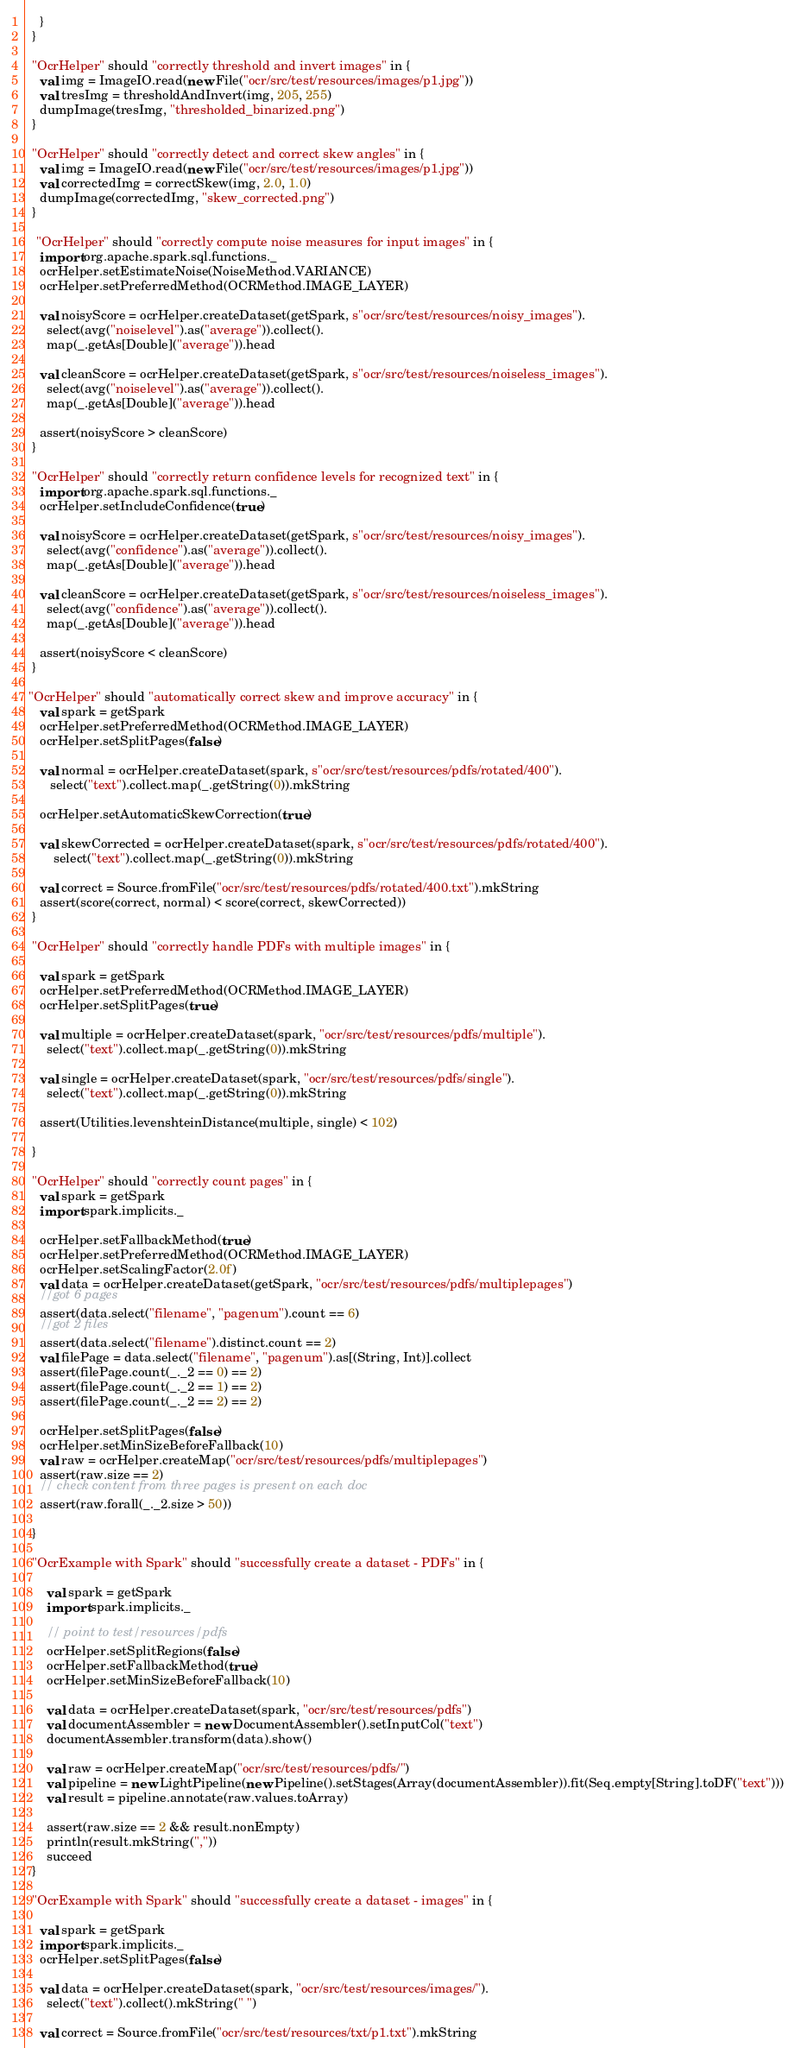<code> <loc_0><loc_0><loc_500><loc_500><_Scala_>    }
  }

  "OcrHelper" should "correctly threshold and invert images" in {
    val img = ImageIO.read(new File("ocr/src/test/resources/images/p1.jpg"))
    val tresImg = thresholdAndInvert(img, 205, 255)
    dumpImage(tresImg, "thresholded_binarized.png")
  }

  "OcrHelper" should "correctly detect and correct skew angles" in {
    val img = ImageIO.read(new File("ocr/src/test/resources/images/p1.jpg"))
    val correctedImg = correctSkew(img, 2.0, 1.0)
    dumpImage(correctedImg, "skew_corrected.png")
  }

   "OcrHelper" should "correctly compute noise measures for input images" in {
    import org.apache.spark.sql.functions._
    ocrHelper.setEstimateNoise(NoiseMethod.VARIANCE)
    ocrHelper.setPreferredMethod(OCRMethod.IMAGE_LAYER)

    val noisyScore = ocrHelper.createDataset(getSpark, s"ocr/src/test/resources/noisy_images").
      select(avg("noiselevel").as("average")).collect().
      map(_.getAs[Double]("average")).head

    val cleanScore = ocrHelper.createDataset(getSpark, s"ocr/src/test/resources/noiseless_images").
      select(avg("noiselevel").as("average")).collect().
      map(_.getAs[Double]("average")).head

    assert(noisyScore > cleanScore)
  }

  "OcrHelper" should "correctly return confidence levels for recognized text" in {
    import org.apache.spark.sql.functions._
    ocrHelper.setIncludeConfidence(true)

    val noisyScore = ocrHelper.createDataset(getSpark, s"ocr/src/test/resources/noisy_images").
      select(avg("confidence").as("average")).collect().
      map(_.getAs[Double]("average")).head

    val cleanScore = ocrHelper.createDataset(getSpark, s"ocr/src/test/resources/noiseless_images").
      select(avg("confidence").as("average")).collect().
      map(_.getAs[Double]("average")).head

    assert(noisyScore < cleanScore)
  }

 "OcrHelper" should "automatically correct skew and improve accuracy" in {
    val spark = getSpark
    ocrHelper.setPreferredMethod(OCRMethod.IMAGE_LAYER)
    ocrHelper.setSplitPages(false)

    val normal = ocrHelper.createDataset(spark, s"ocr/src/test/resources/pdfs/rotated/400").
       select("text").collect.map(_.getString(0)).mkString

    ocrHelper.setAutomaticSkewCorrection(true)

    val skewCorrected = ocrHelper.createDataset(spark, s"ocr/src/test/resources/pdfs/rotated/400").
        select("text").collect.map(_.getString(0)).mkString

    val correct = Source.fromFile("ocr/src/test/resources/pdfs/rotated/400.txt").mkString
    assert(score(correct, normal) < score(correct, skewCorrected))
  }

  "OcrHelper" should "correctly handle PDFs with multiple images" in {

    val spark = getSpark
    ocrHelper.setPreferredMethod(OCRMethod.IMAGE_LAYER)
    ocrHelper.setSplitPages(true)

    val multiple = ocrHelper.createDataset(spark, "ocr/src/test/resources/pdfs/multiple").
      select("text").collect.map(_.getString(0)).mkString

    val single = ocrHelper.createDataset(spark, "ocr/src/test/resources/pdfs/single").
      select("text").collect.map(_.getString(0)).mkString

    assert(Utilities.levenshteinDistance(multiple, single) < 102)

  }

  "OcrHelper" should "correctly count pages" in {
    val spark = getSpark
    import spark.implicits._

    ocrHelper.setFallbackMethod(true)
    ocrHelper.setPreferredMethod(OCRMethod.IMAGE_LAYER)
    ocrHelper.setScalingFactor(2.0f)
    val data = ocrHelper.createDataset(getSpark, "ocr/src/test/resources/pdfs/multiplepages")
    //got 6 pages
    assert(data.select("filename", "pagenum").count == 6)
    //got 2 files
    assert(data.select("filename").distinct.count == 2)
    val filePage = data.select("filename", "pagenum").as[(String, Int)].collect
    assert(filePage.count(_._2 == 0) == 2)
    assert(filePage.count(_._2 == 1) == 2)
    assert(filePage.count(_._2 == 2) == 2)

    ocrHelper.setSplitPages(false)
    ocrHelper.setMinSizeBeforeFallback(10)
    val raw = ocrHelper.createMap("ocr/src/test/resources/pdfs/multiplepages")
    assert(raw.size == 2)
    // check content from three pages is present on each doc
    assert(raw.forall(_._2.size > 50))

  }

  "OcrExample with Spark" should "successfully create a dataset - PDFs" in {

      val spark = getSpark
      import spark.implicits._

      // point to test/resources/pdfs
      ocrHelper.setSplitRegions(false)
      ocrHelper.setFallbackMethod(true)
      ocrHelper.setMinSizeBeforeFallback(10)

      val data = ocrHelper.createDataset(spark, "ocr/src/test/resources/pdfs")
      val documentAssembler = new DocumentAssembler().setInputCol("text")
      documentAssembler.transform(data).show()

      val raw = ocrHelper.createMap("ocr/src/test/resources/pdfs/")
      val pipeline = new LightPipeline(new Pipeline().setStages(Array(documentAssembler)).fit(Seq.empty[String].toDF("text")))
      val result = pipeline.annotate(raw.values.toArray)

      assert(raw.size == 2 && result.nonEmpty)
      println(result.mkString(","))
      succeed
  }

  "OcrExample with Spark" should "successfully create a dataset - images" in {

    val spark = getSpark
    import spark.implicits._
    ocrHelper.setSplitPages(false)

    val data = ocrHelper.createDataset(spark, "ocr/src/test/resources/images/").
      select("text").collect().mkString(" ")

    val correct = Source.fromFile("ocr/src/test/resources/txt/p1.txt").mkString</code> 